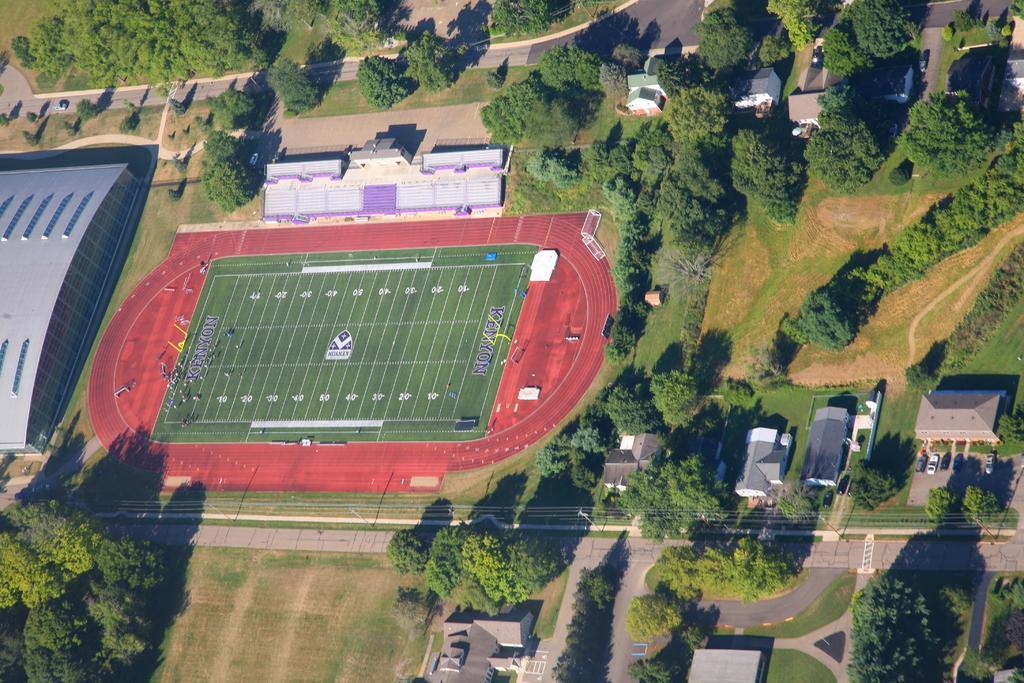Can you describe this image briefly? This is the top view image. On the right side there are houses, roofs, vehicles on the ground, trees and grass on the ground. On the left side there is a building, trees and grass on the ground, playing ground, court on the ground and vehicles on the road. 